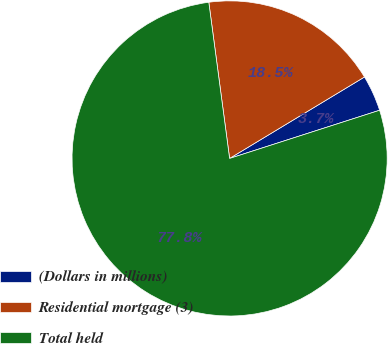Convert chart. <chart><loc_0><loc_0><loc_500><loc_500><pie_chart><fcel>(Dollars in millions)<fcel>Residential mortgage (3)<fcel>Total held<nl><fcel>3.7%<fcel>18.46%<fcel>77.83%<nl></chart> 